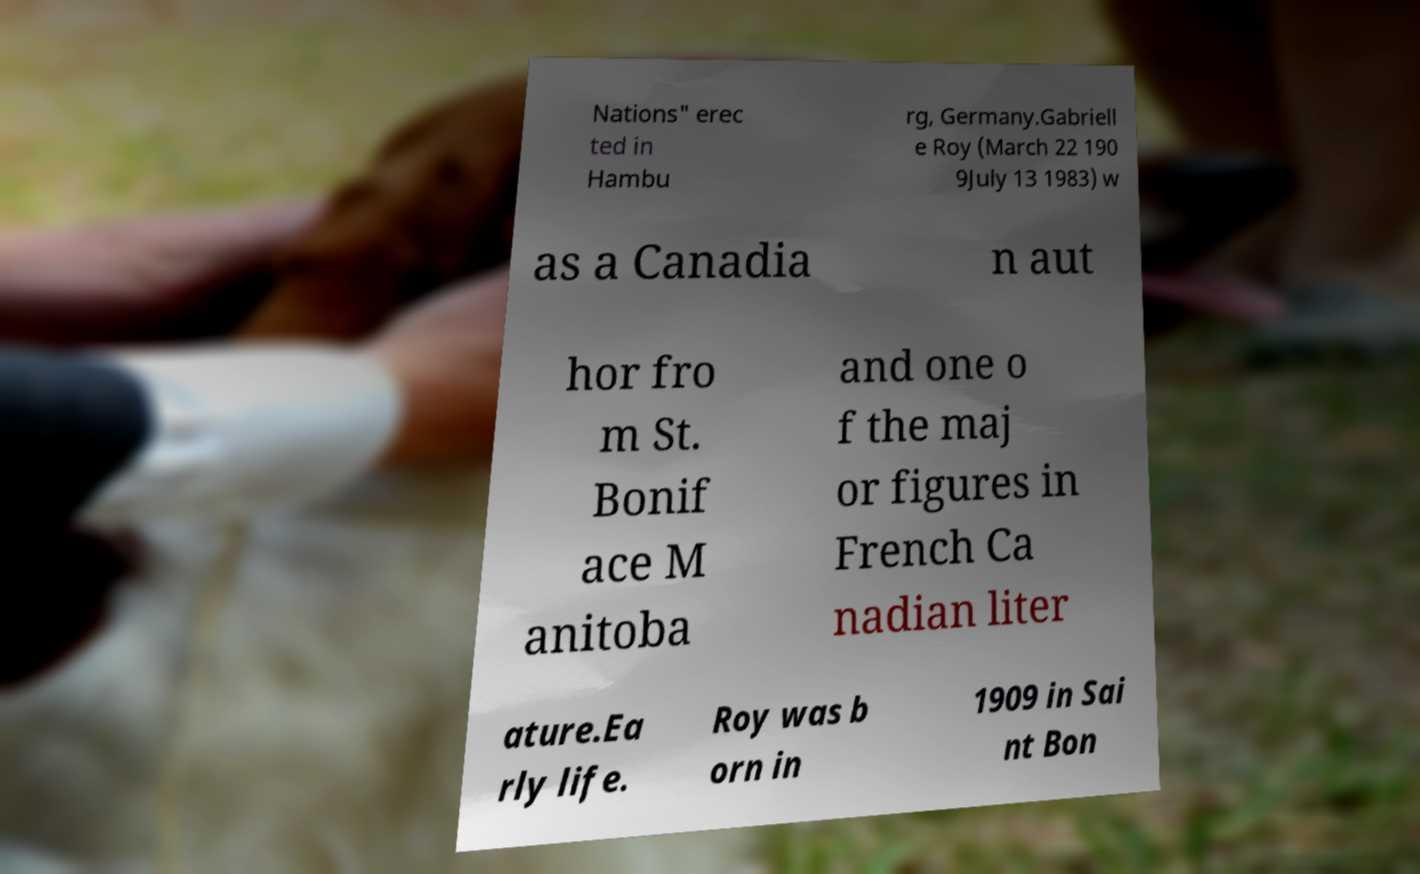For documentation purposes, I need the text within this image transcribed. Could you provide that? Nations" erec ted in Hambu rg, Germany.Gabriell e Roy (March 22 190 9July 13 1983) w as a Canadia n aut hor fro m St. Bonif ace M anitoba and one o f the maj or figures in French Ca nadian liter ature.Ea rly life. Roy was b orn in 1909 in Sai nt Bon 